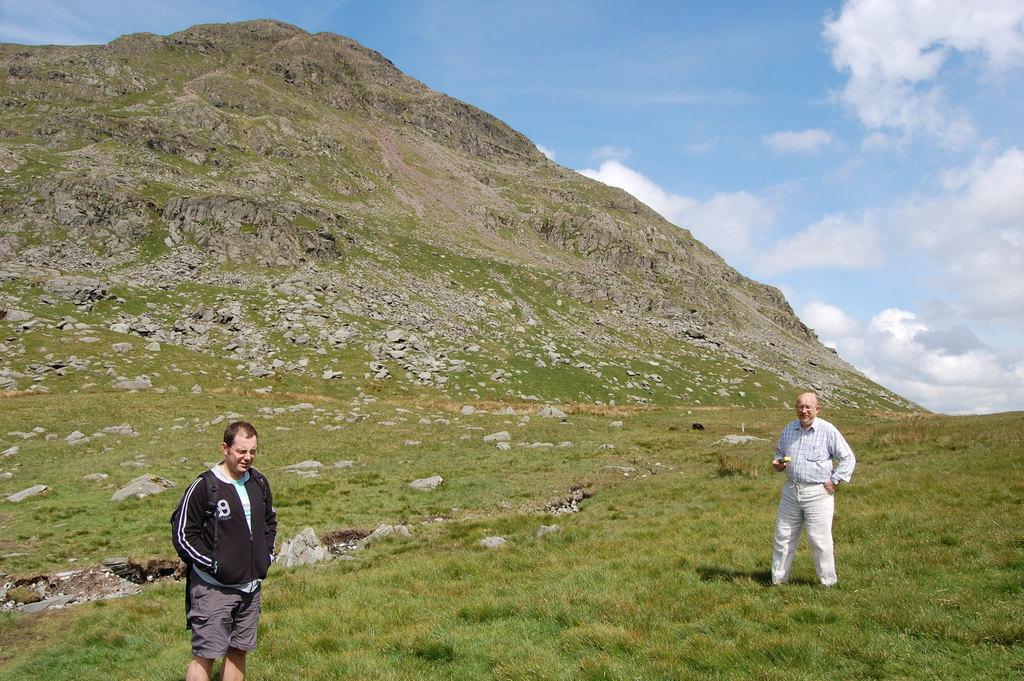Please provide a concise description of this image. At the bottom of the picture, we see a man in the black jacket is standing. At the bottom, we see the grass. The man in the white shirt is standing. In the background, we see the stones and a hill. At the top, we see the sky and the clouds. 